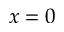Convert formula to latex. <formula><loc_0><loc_0><loc_500><loc_500>x = 0</formula> 